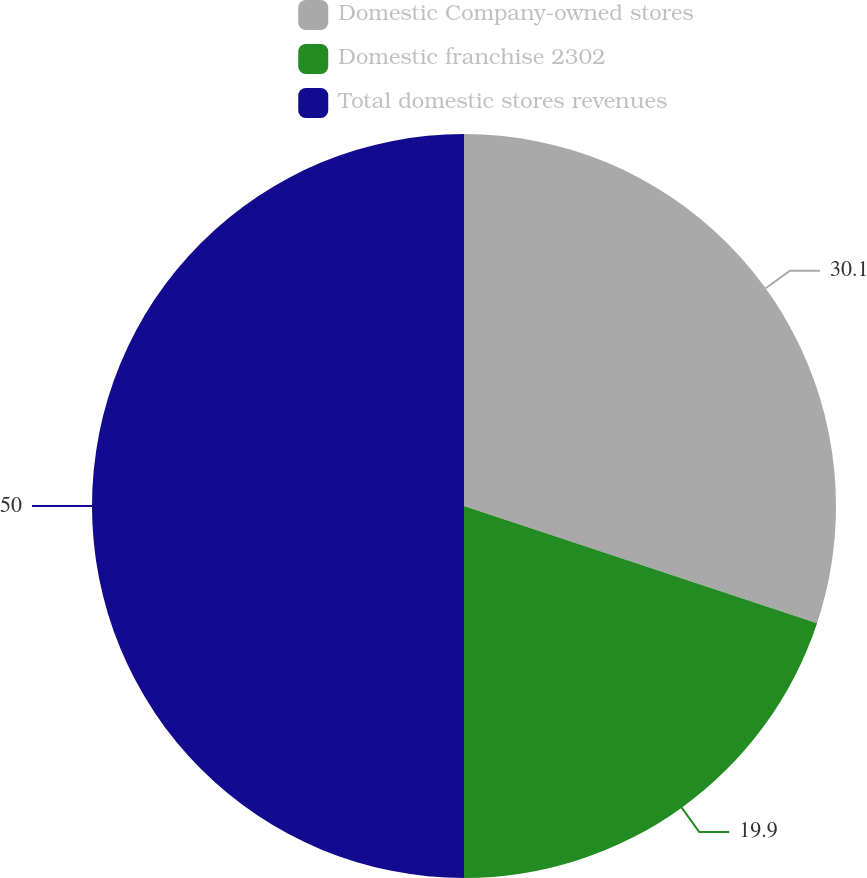Convert chart. <chart><loc_0><loc_0><loc_500><loc_500><pie_chart><fcel>Domestic Company-owned stores<fcel>Domestic franchise 2302<fcel>Total domestic stores revenues<nl><fcel>30.1%<fcel>19.9%<fcel>50.0%<nl></chart> 